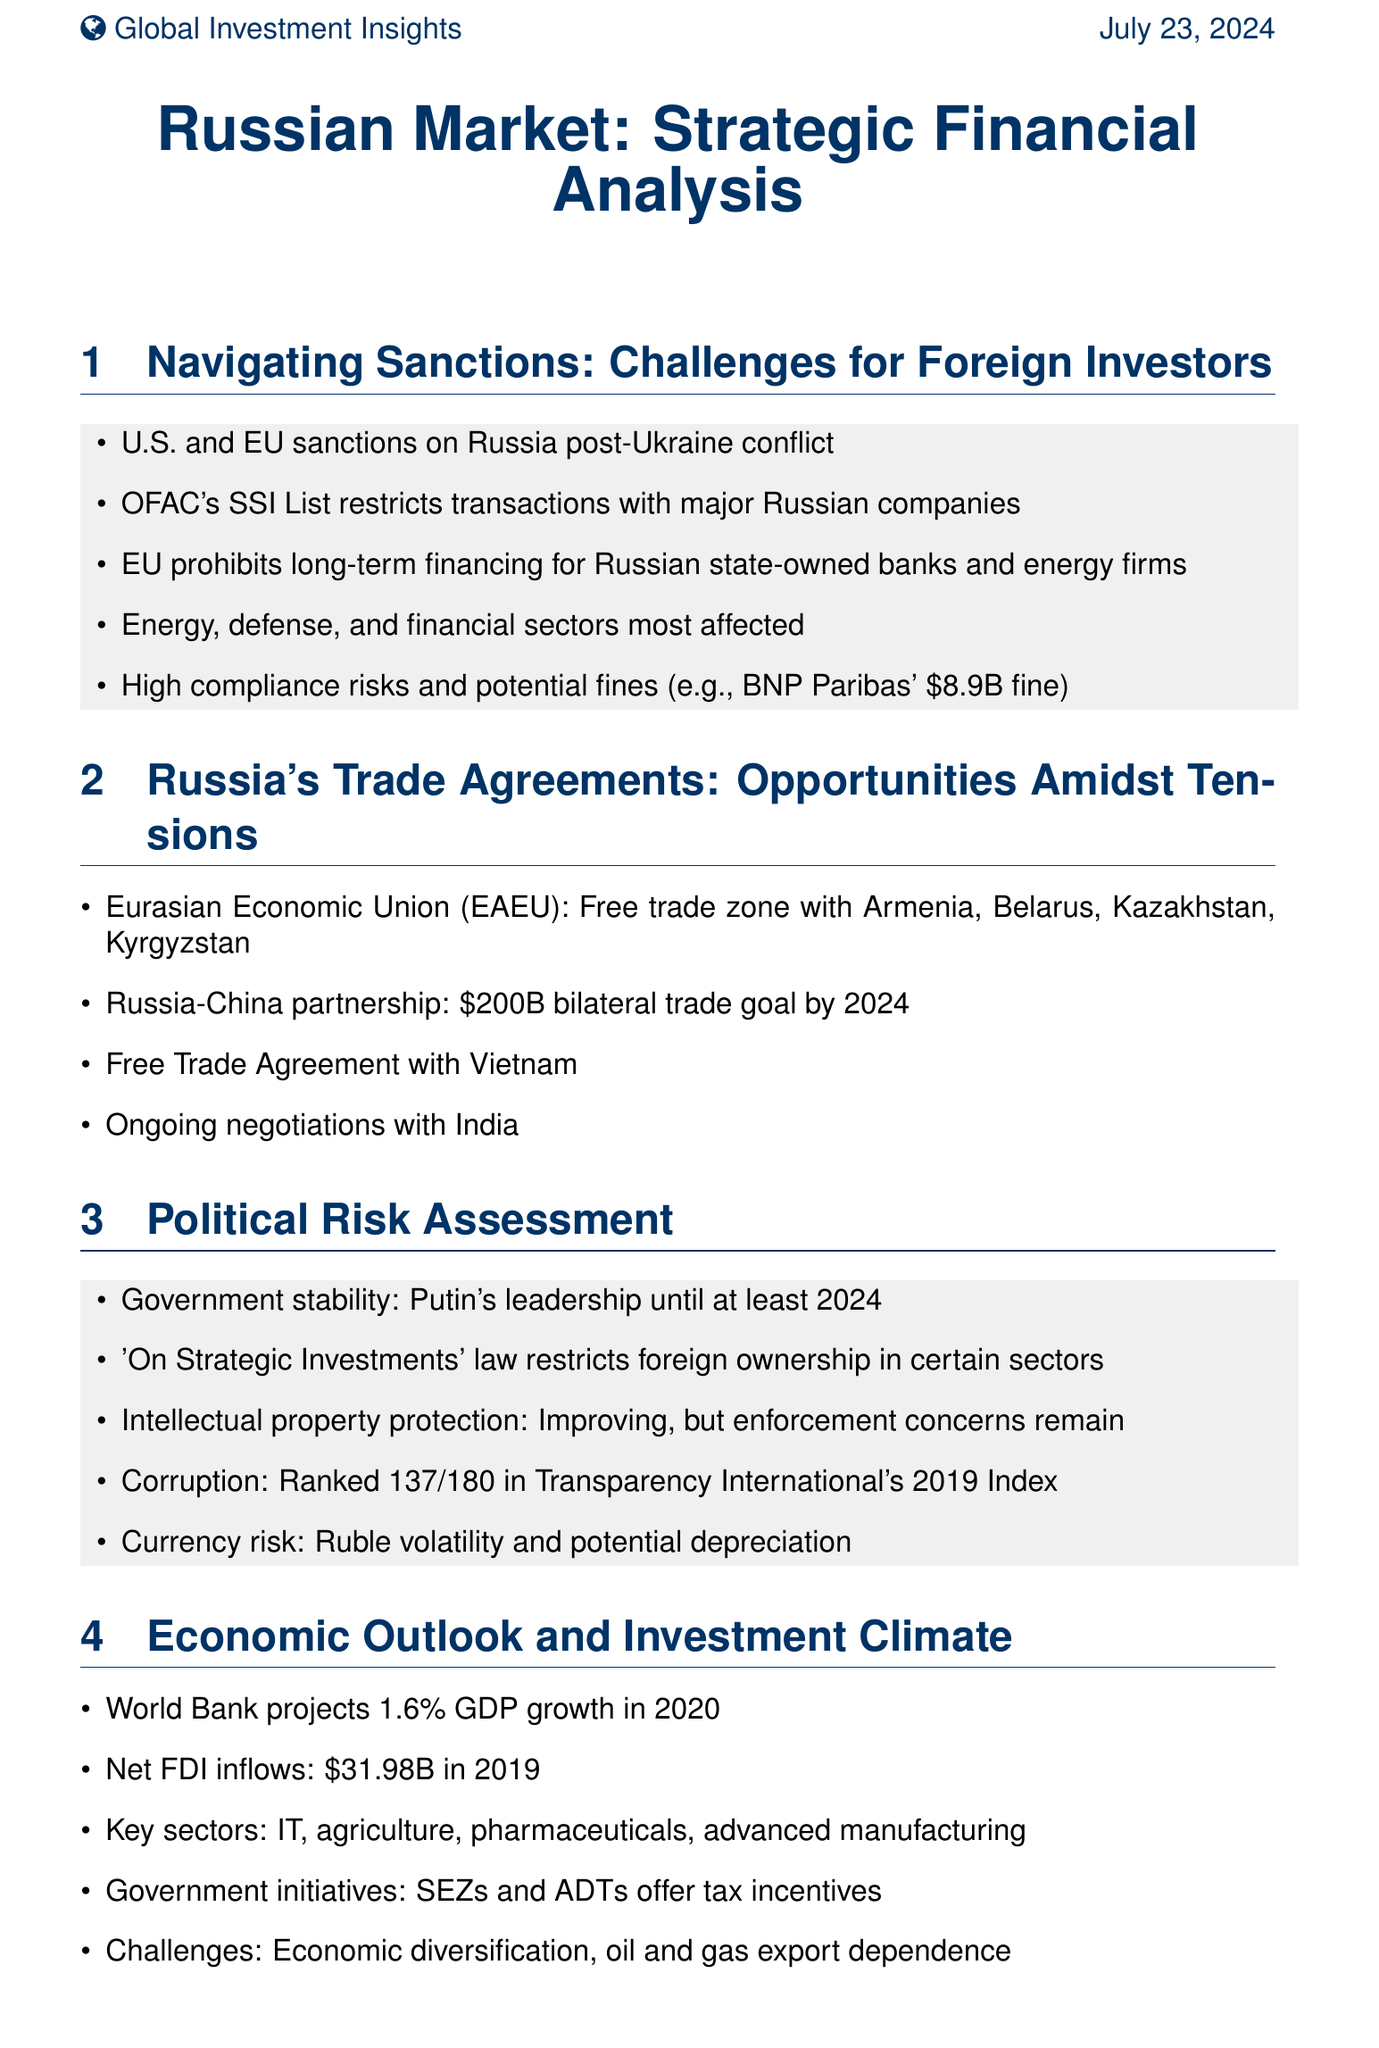What are the key sectors most affected by sanctions? The document lists energy, defense, and financial sectors as the most affected by sanctions.
Answer: energy, defense, and financial sectors What is the GDP growth projected by the World Bank for 2020? The document states that the World Bank projects a GDP growth of 1.6% in 2020.
Answer: 1.6% Which countries are part of the Eurasian Economic Union? The document mentions Armenia, Belarus, Kazakhstan, and Kyrgyzstan as part of the EAEU.
Answer: Armenia, Belarus, Kazakhstan, Kyrgyzstan What is the corporate tax rate in Russia? The document specifies that the corporate tax rate is 20%.
Answer: 20% What significant fine did BNP Paribas face for sanctions violations? The document notes that BNP Paribas faced a fine of $8.9 billion in 2014.
Answer: $8.9 billion What is Russia's bilateral trade goal with China by 2024? According to the document, Russia and China aim for a bilateral trade goal of $200 billion by 2024.
Answer: $200 billion What rank does Russia hold in Transparency International's 2019 Corruption Perceptions Index? The document indicates that Russia is ranked 137 out of 180 countries in this index.
Answer: 137 What law restricts foreign ownership in certain sectors in Russia? The document refers to the 'On Strategic Investments' law as restricting foreign ownership in specific sectors.
Answer: 'On Strategic Investments' law 